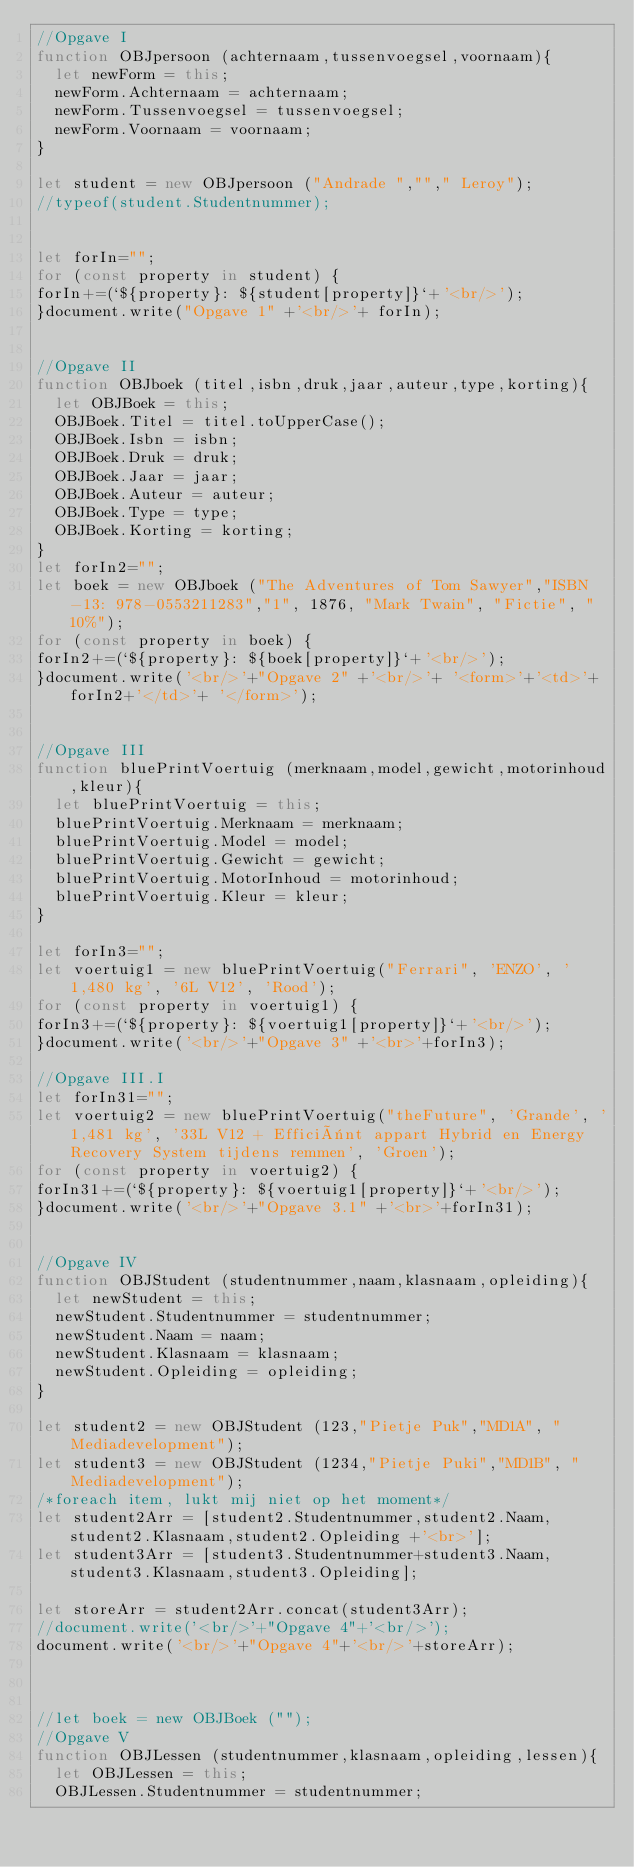<code> <loc_0><loc_0><loc_500><loc_500><_JavaScript_>//Opgave I
function OBJpersoon (achternaam,tussenvoegsel,voornaam){
  let newForm = this;
  newForm.Achternaam = achternaam;
  newForm.Tussenvoegsel = tussenvoegsel;
  newForm.Voornaam = voornaam;
}

let student = new OBJpersoon ("Andrade ",""," Leroy");
//typeof(student.Studentnummer);


let forIn="";
for (const property in student) {
forIn+=(`${property}: ${student[property]}`+'<br/>');
}document.write("Opgave 1" +'<br/>'+ forIn);


//Opgave II
function OBJboek (titel,isbn,druk,jaar,auteur,type,korting){
  let OBJBoek = this;
  OBJBoek.Titel = titel.toUpperCase();
  OBJBoek.Isbn = isbn;
  OBJBoek.Druk = druk;
  OBJBoek.Jaar = jaar;
  OBJBoek.Auteur = auteur;
  OBJBoek.Type = type;
  OBJBoek.Korting = korting;
}
let forIn2="";
let boek = new OBJboek ("The Adventures of Tom Sawyer","ISBN-13: 978-0553211283","1", 1876, "Mark Twain", "Fictie", "10%");
for (const property in boek) {
forIn2+=(`${property}: ${boek[property]}`+'<br/>');
}document.write('<br/>'+"Opgave 2" +'<br/>'+ '<form>'+'<td>'+forIn2+'</td>'+ '</form>');


//Opgave III
function bluePrintVoertuig (merknaam,model,gewicht,motorinhoud,kleur){
  let bluePrintVoertuig = this;
  bluePrintVoertuig.Merknaam = merknaam;
  bluePrintVoertuig.Model = model;
  bluePrintVoertuig.Gewicht = gewicht;
  bluePrintVoertuig.MotorInhoud = motorinhoud;
  bluePrintVoertuig.Kleur = kleur;
}

let forIn3="";
let voertuig1 = new bluePrintVoertuig("Ferrari", 'ENZO', '1,480 kg', '6L V12', 'Rood');
for (const property in voertuig1) {
forIn3+=(`${property}: ${voertuig1[property]}`+'<br/>');
}document.write('<br/>'+"Opgave 3" +'<br>'+forIn3);

//Opgave III.I
let forIn31="";
let voertuig2 = new bluePrintVoertuig("theFuture", 'Grande', '1,481 kg', '33L V12 + Efficiënt appart Hybrid en Energy Recovery System tijdens remmen', 'Groen');
for (const property in voertuig2) {
forIn31+=(`${property}: ${voertuig1[property]}`+'<br/>');
}document.write('<br/>'+"Opgave 3.1" +'<br>'+forIn31);


//Opgave IV
function OBJStudent (studentnummer,naam,klasnaam,opleiding){
  let newStudent = this;
  newStudent.Studentnummer = studentnummer;
  newStudent.Naam = naam;
  newStudent.Klasnaam = klasnaam;
  newStudent.Opleiding = opleiding;
}

let student2 = new OBJStudent (123,"Pietje Puk","MD1A", "Mediadevelopment");
let student3 = new OBJStudent (1234,"Pietje Puki","MD1B", "Mediadevelopment");
/*foreach item, lukt mij niet op het moment*/
let student2Arr = [student2.Studentnummer,student2.Naam,student2.Klasnaam,student2.Opleiding +'<br>'];
let student3Arr = [student3.Studentnummer+student3.Naam,student3.Klasnaam,student3.Opleiding];

let storeArr = student2Arr.concat(student3Arr);
//document.write('<br/>'+"Opgave 4"+'<br/>');
document.write('<br/>'+"Opgave 4"+'<br/>'+storeArr);



//let boek = new OBJBoek ("");
//Opgave V
function OBJLessen (studentnummer,klasnaam,opleiding,lessen){
  let OBJLessen = this;
  OBJLessen.Studentnummer = studentnummer;</code> 